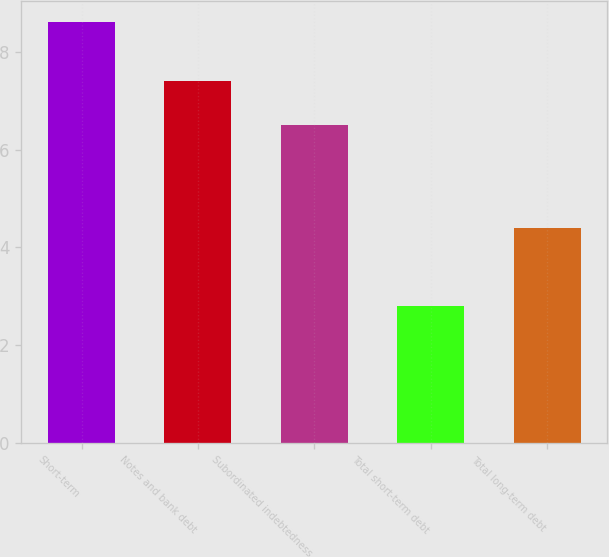<chart> <loc_0><loc_0><loc_500><loc_500><bar_chart><fcel>Short-term<fcel>Notes and bank debt<fcel>Subordinated indebtedness<fcel>Total short-term debt<fcel>Total long-term debt<nl><fcel>8.6<fcel>7.4<fcel>6.5<fcel>2.8<fcel>4.4<nl></chart> 